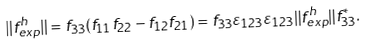<formula> <loc_0><loc_0><loc_500><loc_500>\| f ^ { h } _ { e x p } \| = f _ { 3 3 } ( f _ { 1 1 } f _ { 2 2 } - f _ { 1 2 } f _ { 2 1 } ) = f _ { 3 3 } \varepsilon _ { 1 2 3 } \varepsilon _ { 1 2 3 } \| f ^ { h } _ { e x p } \| f ^ { * } _ { 3 3 } .</formula> 